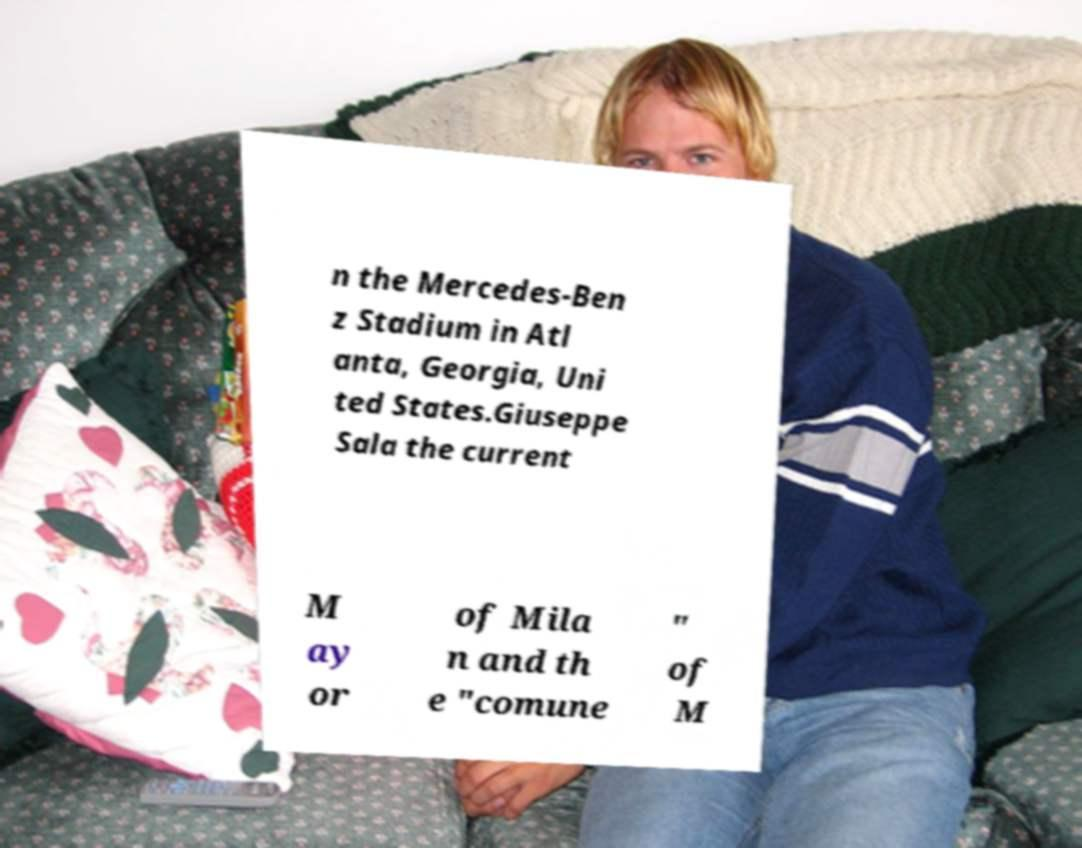For documentation purposes, I need the text within this image transcribed. Could you provide that? n the Mercedes-Ben z Stadium in Atl anta, Georgia, Uni ted States.Giuseppe Sala the current M ay or of Mila n and th e "comune " of M 